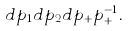Convert formula to latex. <formula><loc_0><loc_0><loc_500><loc_500>d p _ { 1 } d p _ { 2 } d p _ { + } p _ { + } ^ { - 1 } .</formula> 